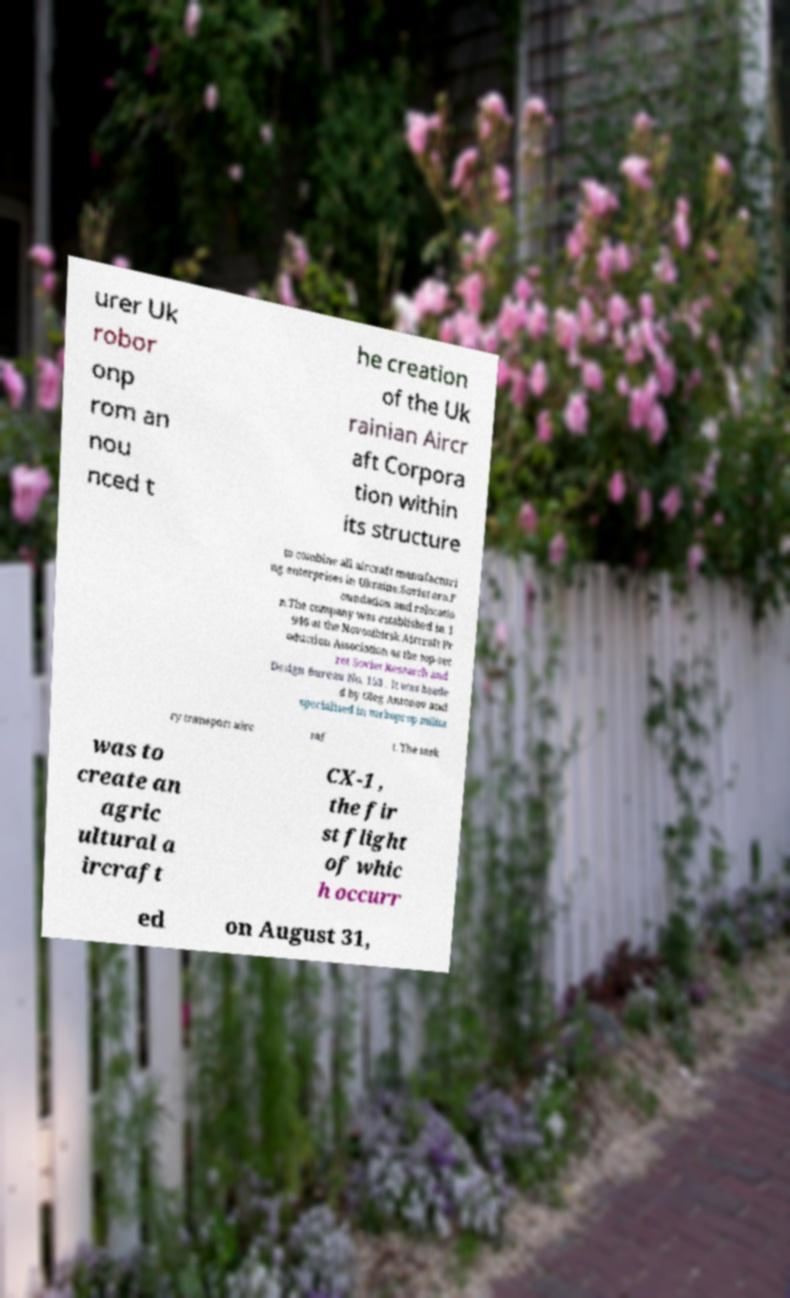Can you accurately transcribe the text from the provided image for me? urer Uk robor onp rom an nou nced t he creation of the Uk rainian Aircr aft Corpora tion within its structure to combine all aircraft manufacturi ng enterprises in Ukraine.Soviet era.F oundation and relocatio n.The company was established in 1 946 at the Novosibirsk Aircraft Pr oduction Association as the top-sec ret Soviet Research and Design Bureau No. 153 . It was heade d by Oleg Antonov and specialised in turboprop milita ry transport airc raf t. The task was to create an agric ultural a ircraft CX-1 , the fir st flight of whic h occurr ed on August 31, 